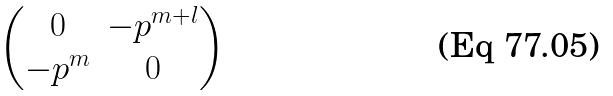<formula> <loc_0><loc_0><loc_500><loc_500>\begin{pmatrix} 0 & - p ^ { m + l } \\ - p ^ { m } & 0 \end{pmatrix}</formula> 